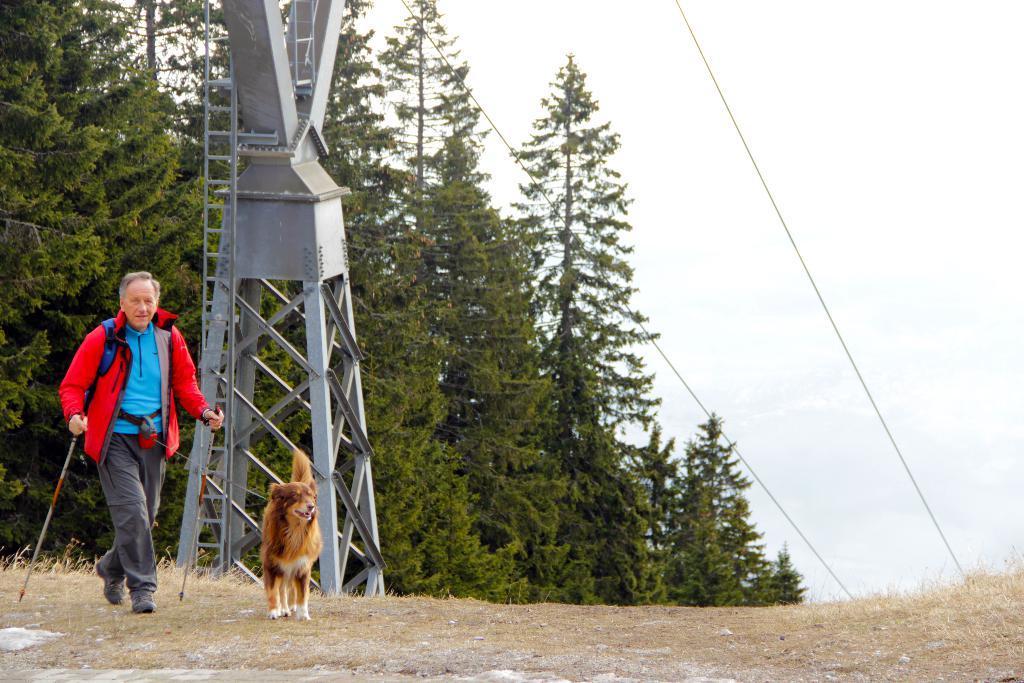Can you describe this image briefly? In this image, I can see a dog and a person walking by holding the trekking poles. Behind the person, there is a ladder to an electric pole, wires and I can see the trees. In the background, there is the sky. 